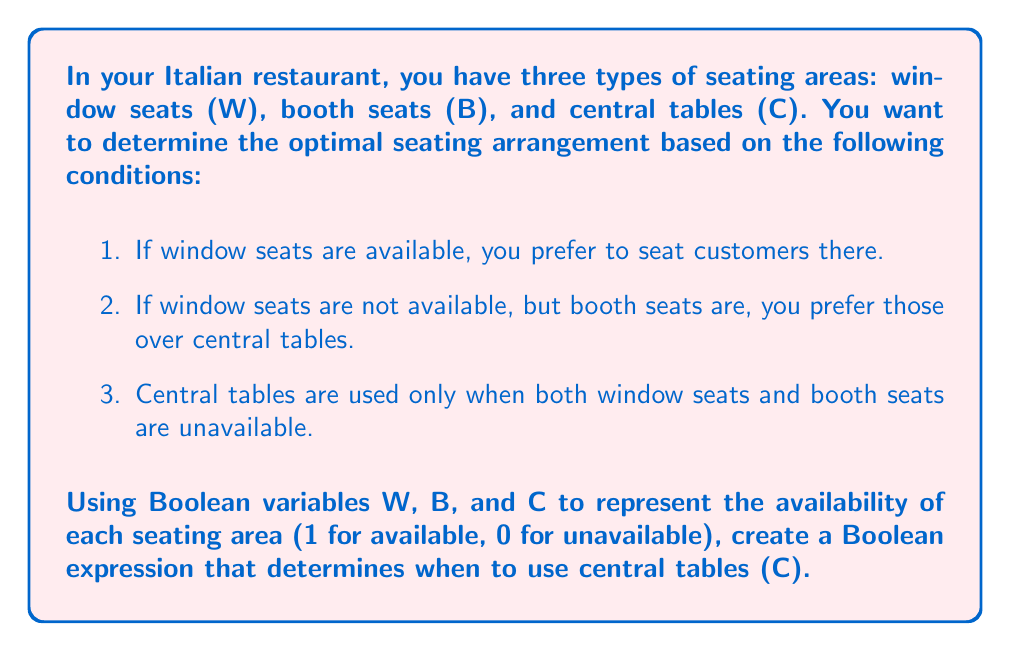Help me with this question. Let's approach this step-by-step using Boolean logic:

1. We need to use central tables (C) when both window seats (W) and booth seats (B) are unavailable.

2. In Boolean terms, a seat being unavailable is represented by the negation of its variable. So, we're looking for the condition where both W and B are false (0).

3. The Boolean expression for "both W and B are false" is:

   $$ \overline{W} \cdot \overline{B} $$

   Where $\overline{W}$ represents "not W" and $\overline{B}$ represents "not B".

4. This expression will be true (1) when both W and B are false (0), which is exactly when we want to use central tables.

5. Therefore, the Boolean expression for when to use central tables (C) is:

   $$ C = \overline{W} \cdot \overline{B} $$

6. This can also be written using the AND operator in programming notation:

   $$ C = !W \text{ AND } !B $$

7. By De Morgan's Law, this is equivalent to:

   $$ C = \overline{W + B} $$

   Which reads as "not (W or B)".
Answer: $C = \overline{W} \cdot \overline{B}$ 